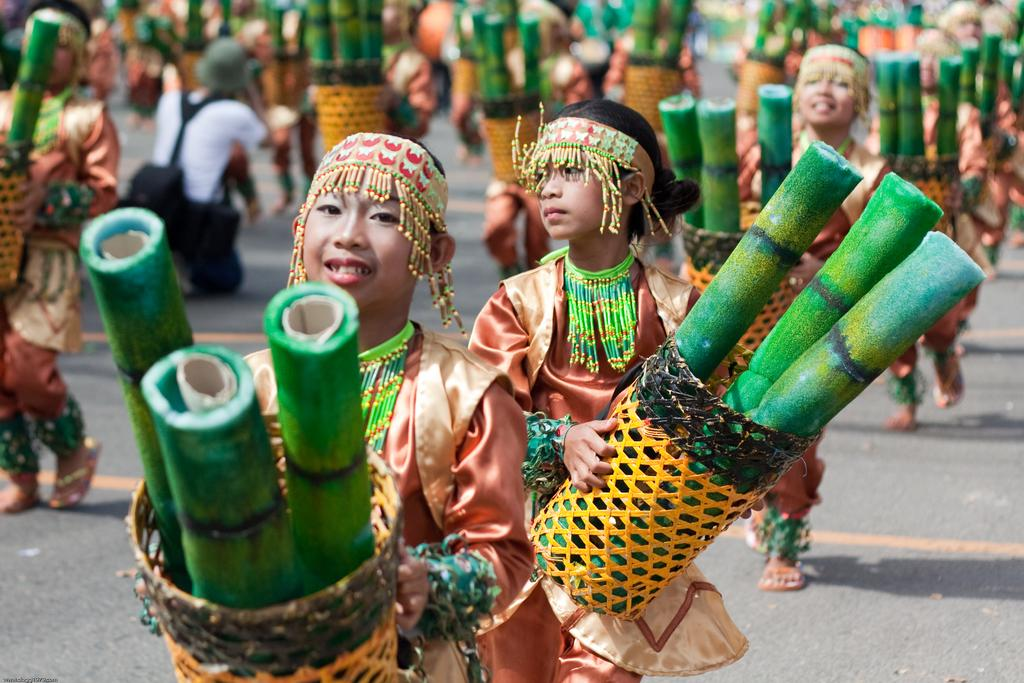How many people are in the group in the image? There is a group of people in the image, but the exact number cannot be determined from the provided facts. What are some people in the group holding? Some people in the group are holding baskets. What can be seen inside the baskets? There are objects visible in the baskets. What type of dress is the person in the front of the line wearing? There is no line present in the image, and no person is mentioned as being in the front. 